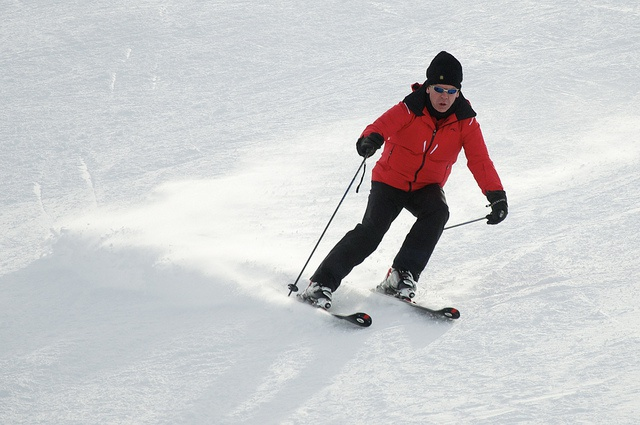Describe the objects in this image and their specific colors. I can see people in lightgray, black, brown, white, and maroon tones and skis in lightgray, black, gray, darkgray, and purple tones in this image. 